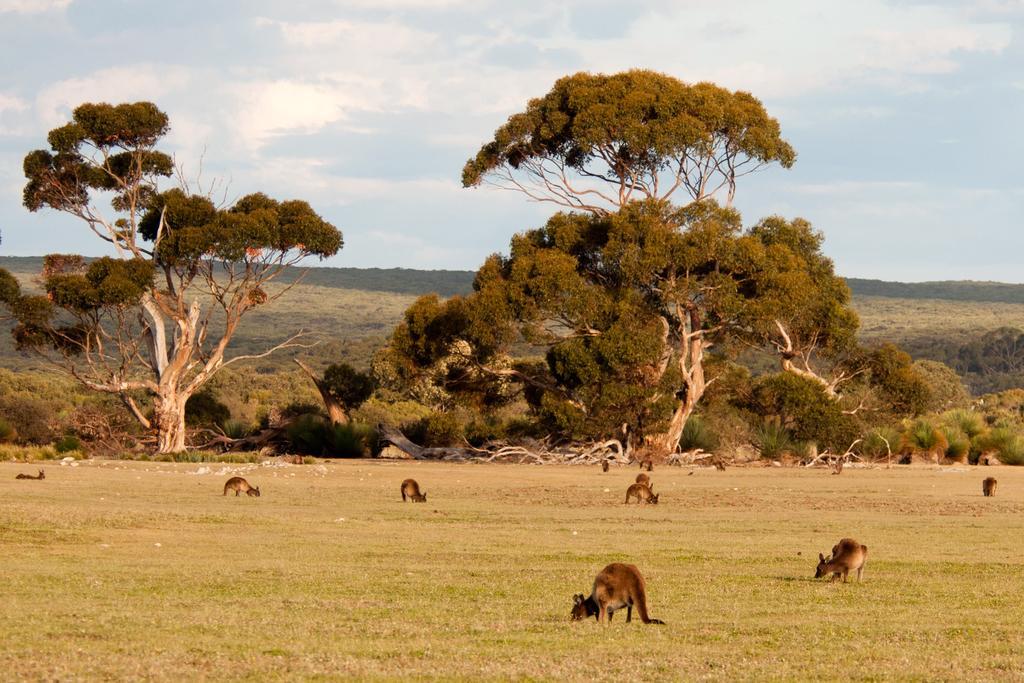Could you give a brief overview of what you see in this image? In this image we can see group of animals standing on the ground. In the background, we can see a group of trees, mountains and the cloudy sky. 